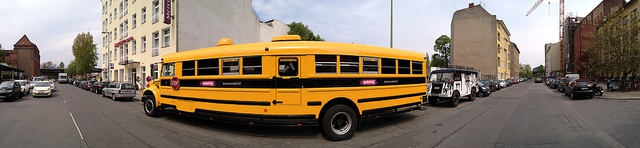Describe the objects in this image and their specific colors. I can see car in white, black, orange, gray, and gold tones, bus in white, black, orange, gold, and olive tones, truck in white, black, gray, darkgray, and lightgray tones, car in white, gray, black, and darkgray tones, and car in white, black, gray, and maroon tones in this image. 